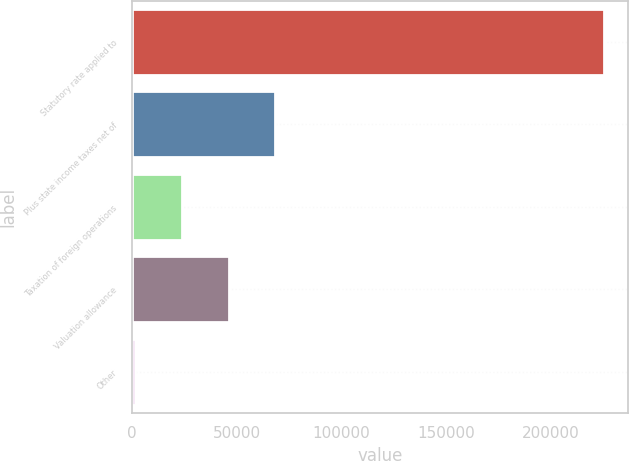Convert chart. <chart><loc_0><loc_0><loc_500><loc_500><bar_chart><fcel>Statutory rate applied to<fcel>Plus state income taxes net of<fcel>Taxation of foreign operations<fcel>Valuation allowance<fcel>Other<nl><fcel>225879<fcel>68552.6<fcel>23602.2<fcel>46077.4<fcel>1127<nl></chart> 